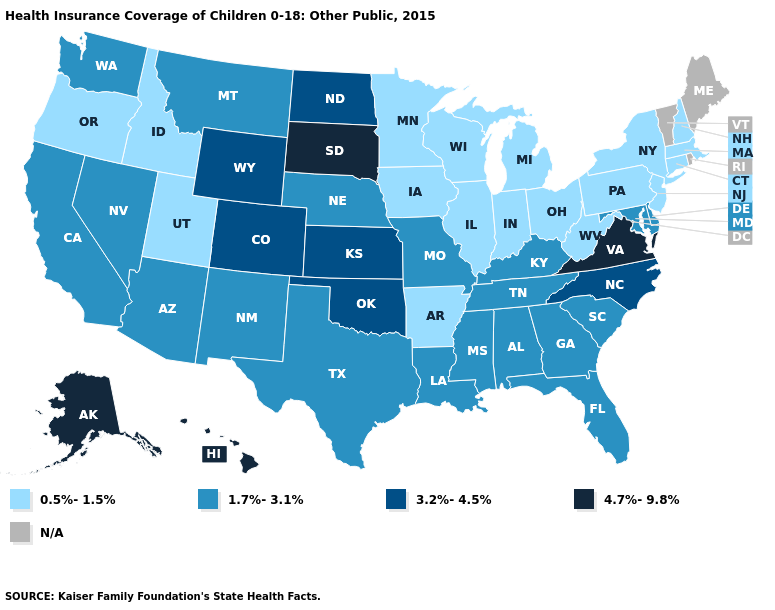Does Arkansas have the lowest value in the South?
Write a very short answer. Yes. Name the states that have a value in the range 1.7%-3.1%?
Write a very short answer. Alabama, Arizona, California, Delaware, Florida, Georgia, Kentucky, Louisiana, Maryland, Mississippi, Missouri, Montana, Nebraska, Nevada, New Mexico, South Carolina, Tennessee, Texas, Washington. Does the first symbol in the legend represent the smallest category?
Answer briefly. Yes. Name the states that have a value in the range N/A?
Quick response, please. Maine, Rhode Island, Vermont. Does the first symbol in the legend represent the smallest category?
Be succinct. Yes. What is the highest value in the USA?
Short answer required. 4.7%-9.8%. Name the states that have a value in the range 1.7%-3.1%?
Quick response, please. Alabama, Arizona, California, Delaware, Florida, Georgia, Kentucky, Louisiana, Maryland, Mississippi, Missouri, Montana, Nebraska, Nevada, New Mexico, South Carolina, Tennessee, Texas, Washington. Does Minnesota have the lowest value in the MidWest?
Give a very brief answer. Yes. What is the value of Colorado?
Quick response, please. 3.2%-4.5%. Among the states that border Indiana , which have the highest value?
Keep it brief. Kentucky. Name the states that have a value in the range 0.5%-1.5%?
Give a very brief answer. Arkansas, Connecticut, Idaho, Illinois, Indiana, Iowa, Massachusetts, Michigan, Minnesota, New Hampshire, New Jersey, New York, Ohio, Oregon, Pennsylvania, Utah, West Virginia, Wisconsin. Which states hav the highest value in the MidWest?
Write a very short answer. South Dakota. What is the highest value in the USA?
Quick response, please. 4.7%-9.8%. Name the states that have a value in the range N/A?
Concise answer only. Maine, Rhode Island, Vermont. Name the states that have a value in the range 4.7%-9.8%?
Short answer required. Alaska, Hawaii, South Dakota, Virginia. 